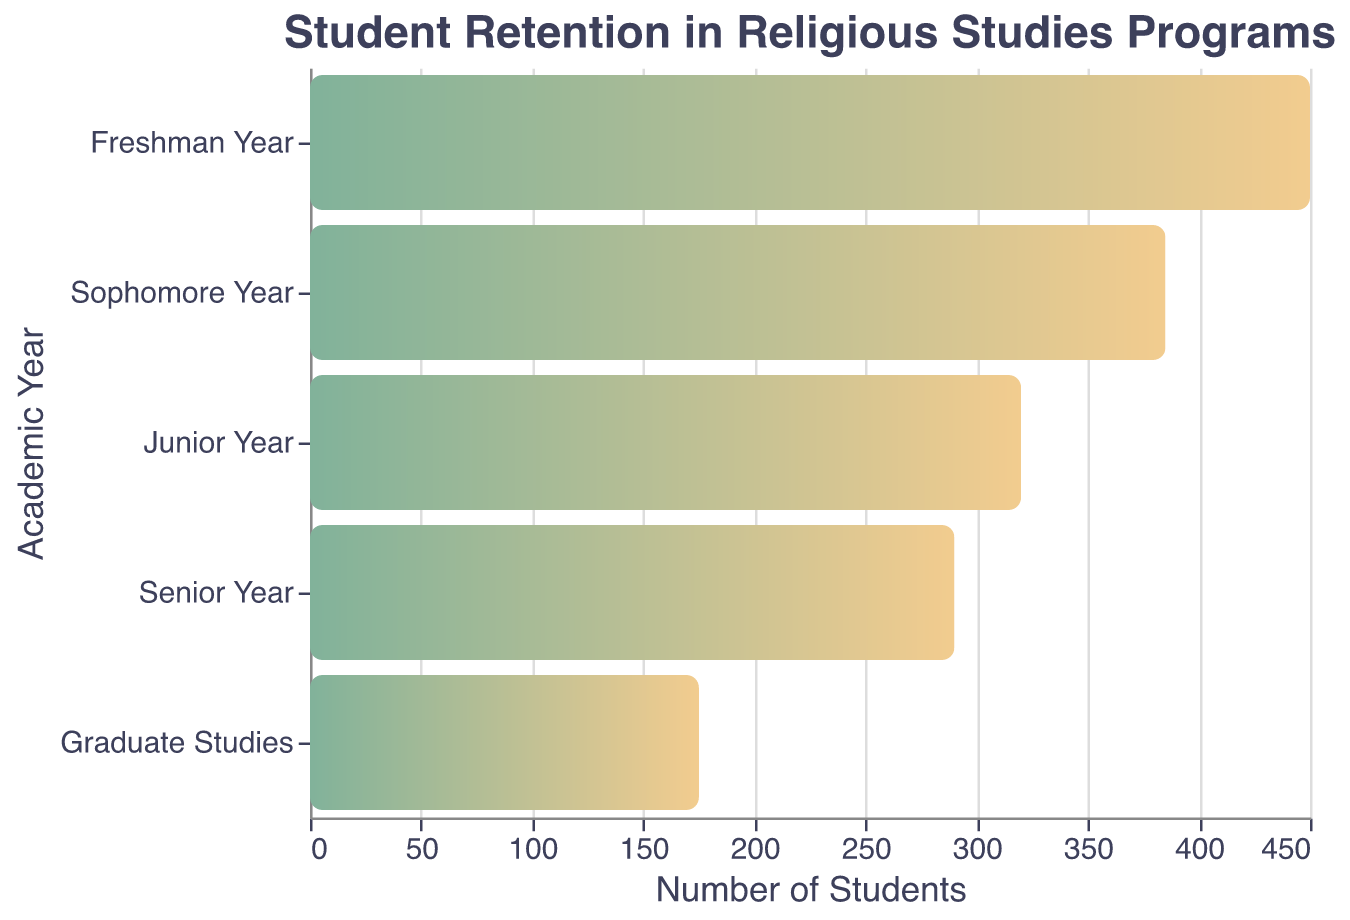How many students are enrolled in the Freshman Year? The bar for the Freshman Year indicates the number of students enrolled. By looking at the x-axis, we can see that the value corresponding to Freshman Year is 450.
Answer: 450 What is the title of the chart? The title of the chart is displayed at the top of the figure. It reads "Student Retention in Religious Studies Programs."
Answer: Student Retention in Religious Studies Programs How many academic years are represented in the chart? By counting the number of distinct bars along the y-axis, which represent each academic year, we find there are five years shown: Freshman Year, Sophomore Year, Junior Year, Senior Year, and Graduate Studies.
Answer: 5 Which academic year has the lowest number of students enrolled? The bar with the smallest length on the x-axis represents the year with the lowest number of students. This is the Graduate Studies bar with 175 students enrolled.
Answer: Graduate Studies What is the difference in student enrollment between the Sophomore Year and Senior Year? To find the difference, subtract the number of students in the Senior Year from the number of students in the Sophomore Year: 385 - 290.
Answer: 95 What is the average number of students enrolled per academic year? To calculate the average, sum the number of students in all academic years (450 + 385 + 320 + 290 + 175), then divide by the number of years (5). The calculation is (450 + 385 + 320 + 290 + 175) / 5 = 1620 / 5.
Answer: 324 How does the student retention rate change from Junior Year to Senior Year? By comparing the number of students enrolled in Junior Year (320) and Senior Year (290), we see a decrease. The retention rate can be calculated as (290 / 320) * 100% ≈ 90.6%.
Answer: Decreases to approximately 90.6% Is there any year where more than 400 students are enrolled? From the x-axis values, only the Freshman Year has more than 400 students enrolled, with a value of 450.
Answer: Yes, Freshman Year Explain the trend in student enrollment from Freshman Year to Graduate Studies. To understand the trend, observe the pattern of student enrollment values across all academic years. From Freshman Year (450) there is a steady decline to Graduate Studies (175). This suggests a decreasing trend in student retention as students progress each year.
Answer: Declining trend 